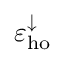<formula> <loc_0><loc_0><loc_500><loc_500>\varepsilon _ { h o } ^ { \downarrow }</formula> 